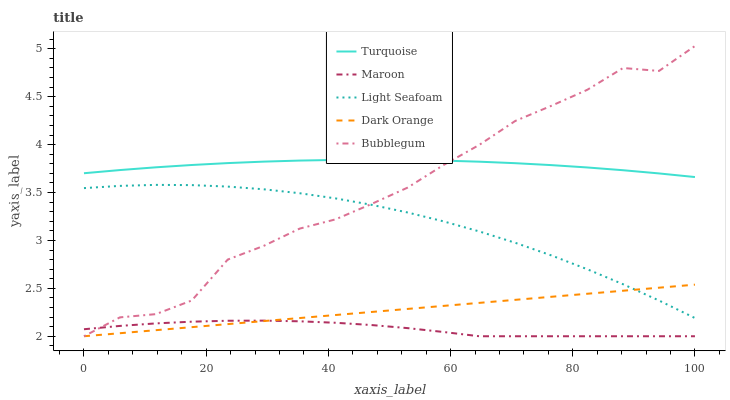Does Maroon have the minimum area under the curve?
Answer yes or no. Yes. Does Turquoise have the maximum area under the curve?
Answer yes or no. Yes. Does Light Seafoam have the minimum area under the curve?
Answer yes or no. No. Does Light Seafoam have the maximum area under the curve?
Answer yes or no. No. Is Dark Orange the smoothest?
Answer yes or no. Yes. Is Bubblegum the roughest?
Answer yes or no. Yes. Is Turquoise the smoothest?
Answer yes or no. No. Is Turquoise the roughest?
Answer yes or no. No. Does Dark Orange have the lowest value?
Answer yes or no. Yes. Does Light Seafoam have the lowest value?
Answer yes or no. No. Does Bubblegum have the highest value?
Answer yes or no. Yes. Does Turquoise have the highest value?
Answer yes or no. No. Is Light Seafoam less than Turquoise?
Answer yes or no. Yes. Is Turquoise greater than Dark Orange?
Answer yes or no. Yes. Does Turquoise intersect Bubblegum?
Answer yes or no. Yes. Is Turquoise less than Bubblegum?
Answer yes or no. No. Is Turquoise greater than Bubblegum?
Answer yes or no. No. Does Light Seafoam intersect Turquoise?
Answer yes or no. No. 